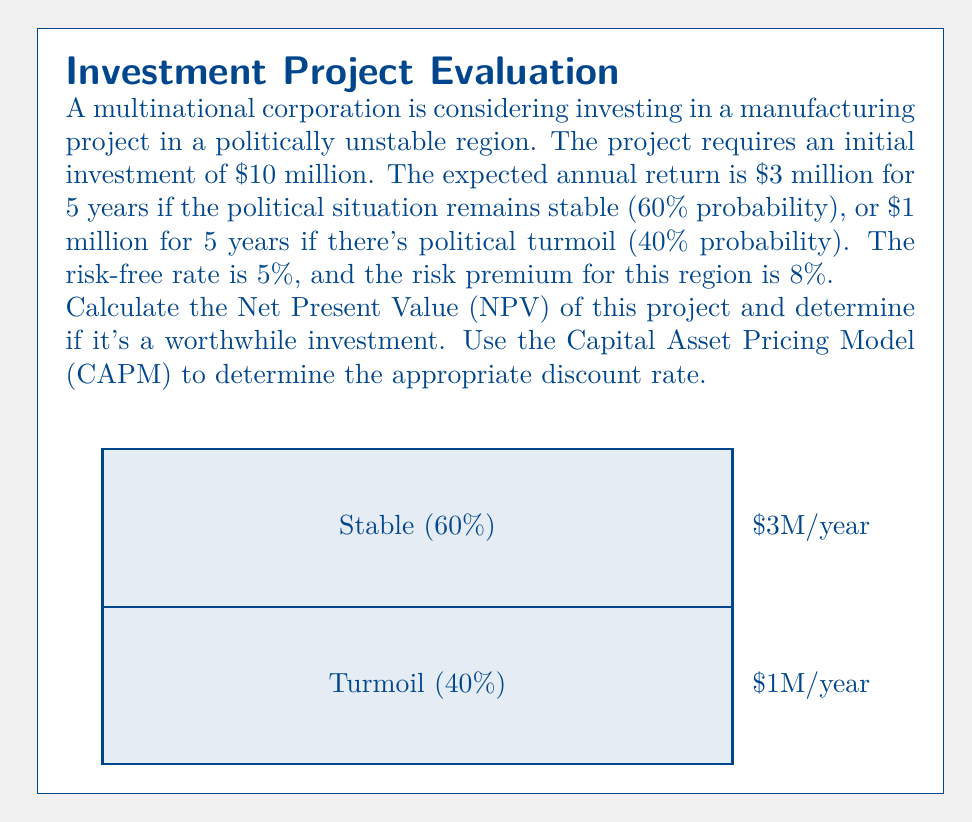Provide a solution to this math problem. Let's approach this step-by-step:

1) First, we need to calculate the discount rate using CAPM:
   $r = r_f + \beta(r_m - r_f)$
   Where $r_f$ is the risk-free rate (5%) and $(r_m - r_f)$ is the risk premium (8%).
   Assuming $\beta = 1$ for simplicity:
   $r = 0.05 + 1(0.08) = 0.13$ or 13%

2) Now, let's calculate the NPV for each scenario:

   Stable scenario (60% probability):
   NPV = -10 + $\sum_{t=1}^5 \frac{3}{(1+0.13)^t}$
   $= -10 + 3(\frac{1-(1+0.13)^{-5}}{0.13}) = 1.03$ million

   Turmoil scenario (40% probability):
   NPV = -10 + $\sum_{t=1}^5 \frac{1}{(1+0.13)^t}$
   $= -10 + 1(\frac{1-(1+0.13)^{-5}}{0.13}) = -6.66$ million

3) The expected NPV is the weighted average of these two scenarios:
   E(NPV) = 0.60(1.03) + 0.40(-6.66) = -2.02 million

4) Since the expected NPV is negative, this investment is not worthwhile based on these calculations.
Answer: $-2.02 million; not a worthwhile investment 